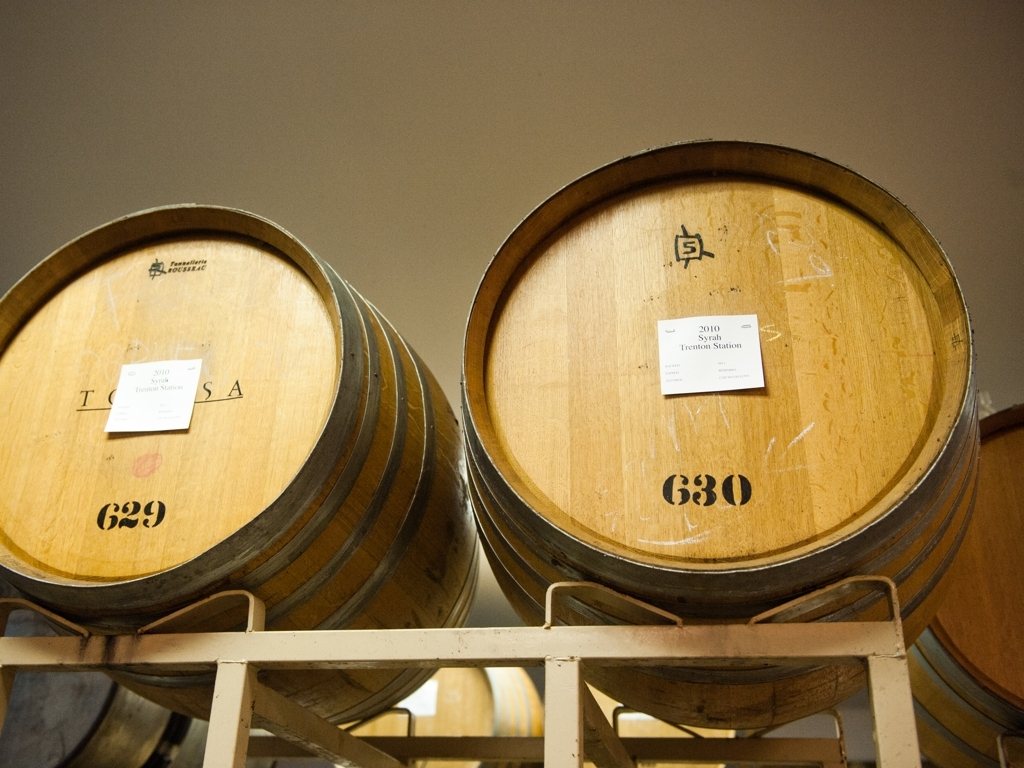Is there any apparent distortion in this photo? Upon close inspection of the image, it appears that there is no significant distortion present. The wooden barrels are proportionate and aligned correctly, and the text on the labels is sharp and readable. The lighting and perspective are consistent throughout the scene, suggesting that the photo captures the space accurately without any noticeable warp or alteration. 